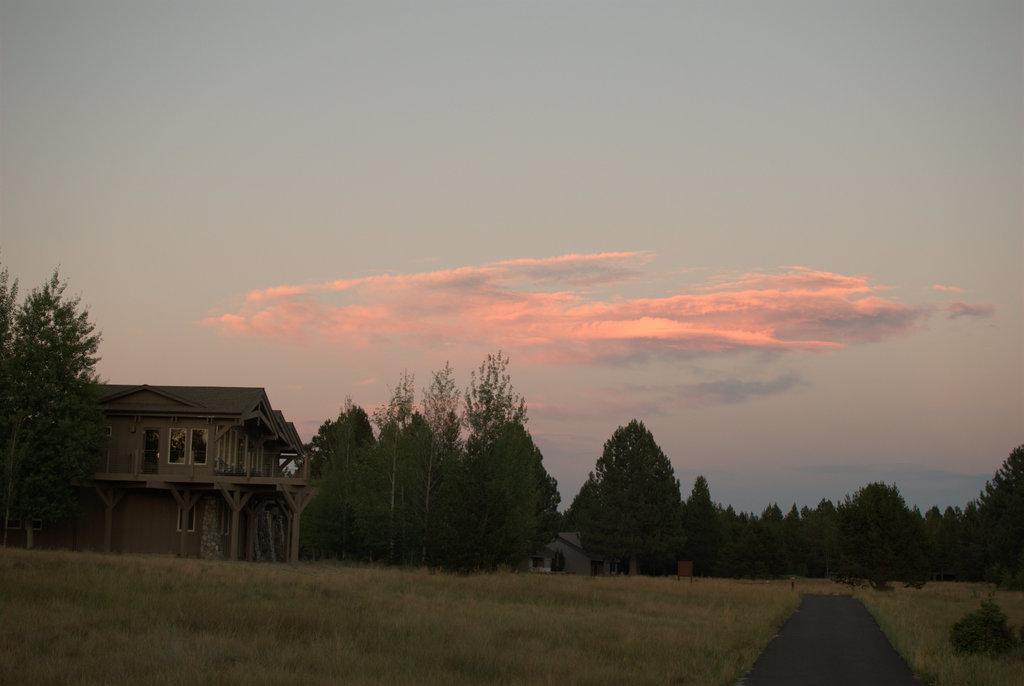Can you describe this image briefly? This looks like a house with the windows. These are the trees with branches and leaves. I think this is the grass. At the bottom of the image, that looks like a road. These are the clouds in the sky. 